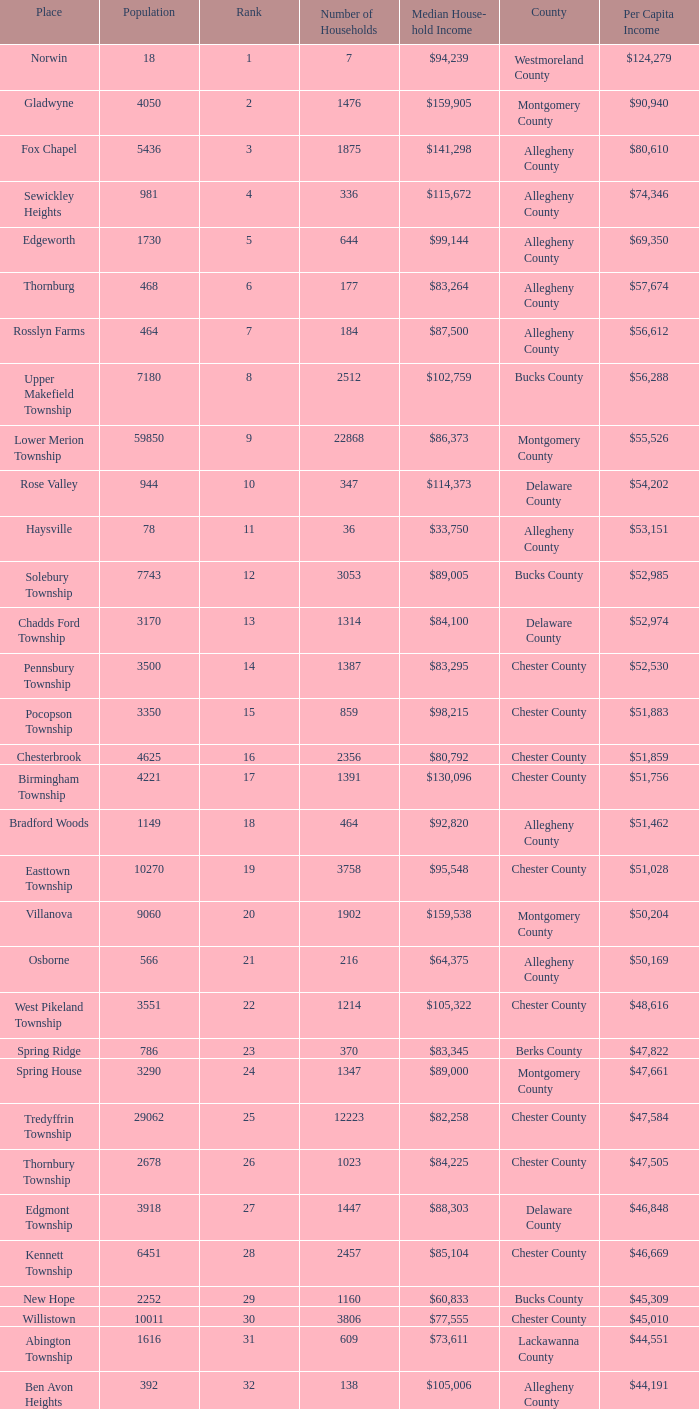Write the full table. {'header': ['Place', 'Population', 'Rank', 'Number of Households', 'Median House- hold Income', 'County', 'Per Capita Income'], 'rows': [['Norwin', '18', '1', '7', '$94,239', 'Westmoreland County', '$124,279'], ['Gladwyne', '4050', '2', '1476', '$159,905', 'Montgomery County', '$90,940'], ['Fox Chapel', '5436', '3', '1875', '$141,298', 'Allegheny County', '$80,610'], ['Sewickley Heights', '981', '4', '336', '$115,672', 'Allegheny County', '$74,346'], ['Edgeworth', '1730', '5', '644', '$99,144', 'Allegheny County', '$69,350'], ['Thornburg', '468', '6', '177', '$83,264', 'Allegheny County', '$57,674'], ['Rosslyn Farms', '464', '7', '184', '$87,500', 'Allegheny County', '$56,612'], ['Upper Makefield Township', '7180', '8', '2512', '$102,759', 'Bucks County', '$56,288'], ['Lower Merion Township', '59850', '9', '22868', '$86,373', 'Montgomery County', '$55,526'], ['Rose Valley', '944', '10', '347', '$114,373', 'Delaware County', '$54,202'], ['Haysville', '78', '11', '36', '$33,750', 'Allegheny County', '$53,151'], ['Solebury Township', '7743', '12', '3053', '$89,005', 'Bucks County', '$52,985'], ['Chadds Ford Township', '3170', '13', '1314', '$84,100', 'Delaware County', '$52,974'], ['Pennsbury Township', '3500', '14', '1387', '$83,295', 'Chester County', '$52,530'], ['Pocopson Township', '3350', '15', '859', '$98,215', 'Chester County', '$51,883'], ['Chesterbrook', '4625', '16', '2356', '$80,792', 'Chester County', '$51,859'], ['Birmingham Township', '4221', '17', '1391', '$130,096', 'Chester County', '$51,756'], ['Bradford Woods', '1149', '18', '464', '$92,820', 'Allegheny County', '$51,462'], ['Easttown Township', '10270', '19', '3758', '$95,548', 'Chester County', '$51,028'], ['Villanova', '9060', '20', '1902', '$159,538', 'Montgomery County', '$50,204'], ['Osborne', '566', '21', '216', '$64,375', 'Allegheny County', '$50,169'], ['West Pikeland Township', '3551', '22', '1214', '$105,322', 'Chester County', '$48,616'], ['Spring Ridge', '786', '23', '370', '$83,345', 'Berks County', '$47,822'], ['Spring House', '3290', '24', '1347', '$89,000', 'Montgomery County', '$47,661'], ['Tredyffrin Township', '29062', '25', '12223', '$82,258', 'Chester County', '$47,584'], ['Thornbury Township', '2678', '26', '1023', '$84,225', 'Chester County', '$47,505'], ['Edgmont Township', '3918', '27', '1447', '$88,303', 'Delaware County', '$46,848'], ['Kennett Township', '6451', '28', '2457', '$85,104', 'Chester County', '$46,669'], ['New Hope', '2252', '29', '1160', '$60,833', 'Bucks County', '$45,309'], ['Willistown', '10011', '30', '3806', '$77,555', 'Chester County', '$45,010'], ['Abington Township', '1616', '31', '609', '$73,611', 'Lackawanna County', '$44,551'], ['Ben Avon Heights', '392', '32', '138', '$105,006', 'Allegheny County', '$44,191'], ['Bala-Cynwyd', '9336', '33', '3726', '$78,932', 'Montgomery County', '$44,027'], ['Lower Makefield Township', '32681', '34', '11706', '$98,090', 'Bucks County', '$43,983'], ['Blue Bell', '6395', '35', '2434', '$94,160', 'Montgomery County', '$43,813'], ['West Vincent Township', '3170', '36', '1077', '$92,024', 'Chester County', '$43,500'], ['Mount Gretna', '242', '37', '117', '$62,917', 'Lebanon County', '$43,470'], ['Schuylkill Township', '6960', '38', '2536', '$86,092', 'Chester County', '$43,379'], ['Fort Washington', '3680', '39', '1161', '$103,469', 'Montgomery County', '$43,090'], ['Marshall Township', '5996', '40', '1944', '$102,351', 'Allegheny County', '$42,856'], ['Woodside', '2575', '41', '791', '$121,151', 'Bucks County', '$42,653'], ['Wrightstown Township', '2839', '42', '971', '$82,875', 'Bucks County', '$42,623'], ['Upper St.Clair Township', '20053', '43', '6966', '$87,581', 'Allegheny County', '$42,413'], ['Seven Springs', '127', '44', '63', '$48,750', 'Fayette County', '$42,131'], ['Charlestown Township', '4051', '45', '1340', '$89,813', 'Chester County', '$41,878'], ['Lower Gwynedd Township', '10422', '46', '4177', '$74,351', 'Montgomery County', '$41,868'], ['Whitpain Township', '18562', '47', '6960', '$88,933', 'Montgomery County', '$41,739'], ['Bell Acres', '1382', '48', '520', '$61,094', 'Allegheny County', '$41,202'], ['Penn Wynne', '5382', '49', '2072', '$78,398', 'Montgomery County', '$41,199'], ['East Bradford Township', '9405', '50', '3076', '$100,732', 'Chester County', '$41,158'], ['Swarthmore', '6170', '51', '1993', '$82,653', 'Delaware County', '$40,482'], ['Lafayette Hill', '10226', '52', '3783', '$84,835', 'Montgomery County', '$40,363'], ['Lower Moreland Township', '11281', '53', '4112', '$82,597', 'Montgomery County', '$40,129'], ['Radnor Township', '30878', '54', '10347', '$74,272', 'Delaware County', '$39,813'], ['Whitemarsh Township', '16702', '55', '6179', '$78,630', 'Montgomery County', '$39,785'], ['Upper Providence Township', '10509', '56', '4075', '$71,166', 'Delaware County', '$39,532'], ['Newtown Township', '11700', '57', '4549', '$65,924', 'Delaware County', '$39,364'], ['Adams Township', '6774', '58', '2382', '$65,357', 'Butler County', '$39,204'], ['Edgewood', '3311', '59', '1639', '$52,153', 'Allegheny County', '$39,188'], ['Dresher', '5610', '60', '1765', '$99,231', 'Montgomery County', '$38,865'], ['Sewickley Hills', '652', '61', '225', '$79,466', 'Allegheny County', '$38,681'], ['Exton', '4267', '62', '2053', '$68,240', 'Chester County', '$38,589'], ['East Marlborough Township', '6317', '63', '2131', '$95,812', 'Chester County', '$38,090'], ['Doylestown Township', '17619', '64', '5999', '$81,226', 'Bucks County', '$38,031'], ['Upper Dublin Township', '25878', '65', '9174', '$80,093', 'Montgomery County', '$37,994'], ['Churchill', '3566', '66', '1519', '$67,321', 'Allegheny County', '$37,964'], ['Franklin Park', '11364', '67', '3866', '$87,627', 'Allegheny County', '$37,924'], ['East Goshen Township', '16824', '68', '7165', '$64,777', 'Chester County', '$37,775'], ['Chester Heights', '2481', '69', '1056', '$70,236', 'Delaware County', '$37,707'], ['McMurray', '4726', '70', '1582', '$81,736', 'Washington County', '$37,364'], ['Wyomissing', '8587', '71', '3359', '$54,681', 'Berks County', '$37,313'], ['Heath Township', '160', '72', '77', '$42,500', 'Jefferson County', '$37,309'], ['Aleppo Township', '1039', '73', '483', '$59,167', 'Allegheny County', '$37,187'], ['Westtown Township', '10352', '74', '3705', '$85,049', 'Chester County', '$36,894'], ['Thompsonville', '3592', '75', '1228', '$75,000', 'Washington County', '$36,853'], ['Flying Hills', '1191', '76', '592', '$59,596', 'Berks County', '$36,822'], ['Newlin Township', '1150', '77', '429', '$68,828', 'Chester County', '$36,804'], ['Wyndmoor', '5601', '78', '2144', '$72,219', 'Montgomery County', '$36,205'], ['Peters Township', '17566', '79', '6026', '$77,442', 'Washington County', '$36,159'], ['Ardmore', '12616', '80', '5529', '$60,966', 'Montgomery County', '$36,111'], ['Clarks Green', '1630', '81', '616', '$61,250', 'Lackawanna County', '$35,975'], ['London Britain Township', '2797', '82', '957', '$93,521', 'Chester County', '$35,761'], ['Buckingham Township', '16422', '83', '5711', '$82,376', 'Bucks County', '$35,735'], ['Devon-Berwyn', '5067', '84', '1978', '$74,886', 'Chester County', '$35,551'], ['North Abington Township', '782', '85', '258', '$57,917', 'Lackawanna County', '$35,537'], ['Malvern', '3059', '86', '1361', '$62,308', 'Chester County', '$35,477'], ['Pine Township', '7683', '87', '2411', '$85,817', 'Allegheny County', '$35,202'], ['Narberth', '4233', '88', '1904', '$60,408', 'Montgomery County', '$35,165'], ['West Whiteland Township', '16499', '89', '6618', '$71,545', 'Chester County', '$35,031'], ['Timber Hills', '329', '90', '157', '$55,938', 'Lebanon County', '$34,974'], ['Upper Merion Township', '26863', '91', '11575', '$65,636', 'Montgomery County', '$34,961'], ['Homewood', '147', '92', '59', '$33,333', 'Beaver County', '$34,486'], ['Newtown Township', '18206', '93', '6761', '$80,532', 'Bucks County', '$34,335'], ['Tinicum Township', '4206', '94', '1674', '$60,843', 'Bucks County', '$34,321'], ['Worcester Township', '7789', '95', '2896', '$77,200', 'Montgomery County', '$34,264'], ['Wyomissing Hills', '2568', '96', '986', '$61,364', 'Berks County', '$34,024'], ['Woodbourne', '3512', '97', '1008', '$107,913', 'Bucks County', '$33,821'], ['Concord Township', '9933', '98', '3384', '$85,503', 'Delaware County', '$33,800'], ['Uwchlan Township', '16576', '99', '5921', '$81,985', 'Chester County', '$33,785']]} Which county has a median household income of  $98,090? Bucks County. 